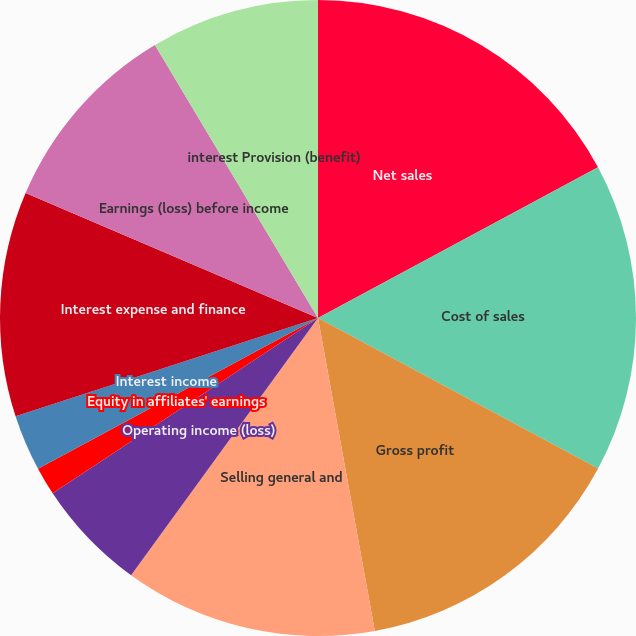Convert chart. <chart><loc_0><loc_0><loc_500><loc_500><pie_chart><fcel>Net sales<fcel>Cost of sales<fcel>Gross profit<fcel>Selling general and<fcel>Operating income (loss)<fcel>Equity in affiliates' earnings<fcel>Interest income<fcel>Interest expense and finance<fcel>Earnings (loss) before income<fcel>interest Provision (benefit)<nl><fcel>17.14%<fcel>15.71%<fcel>14.29%<fcel>12.86%<fcel>5.71%<fcel>1.43%<fcel>2.86%<fcel>11.43%<fcel>10.0%<fcel>8.57%<nl></chart> 